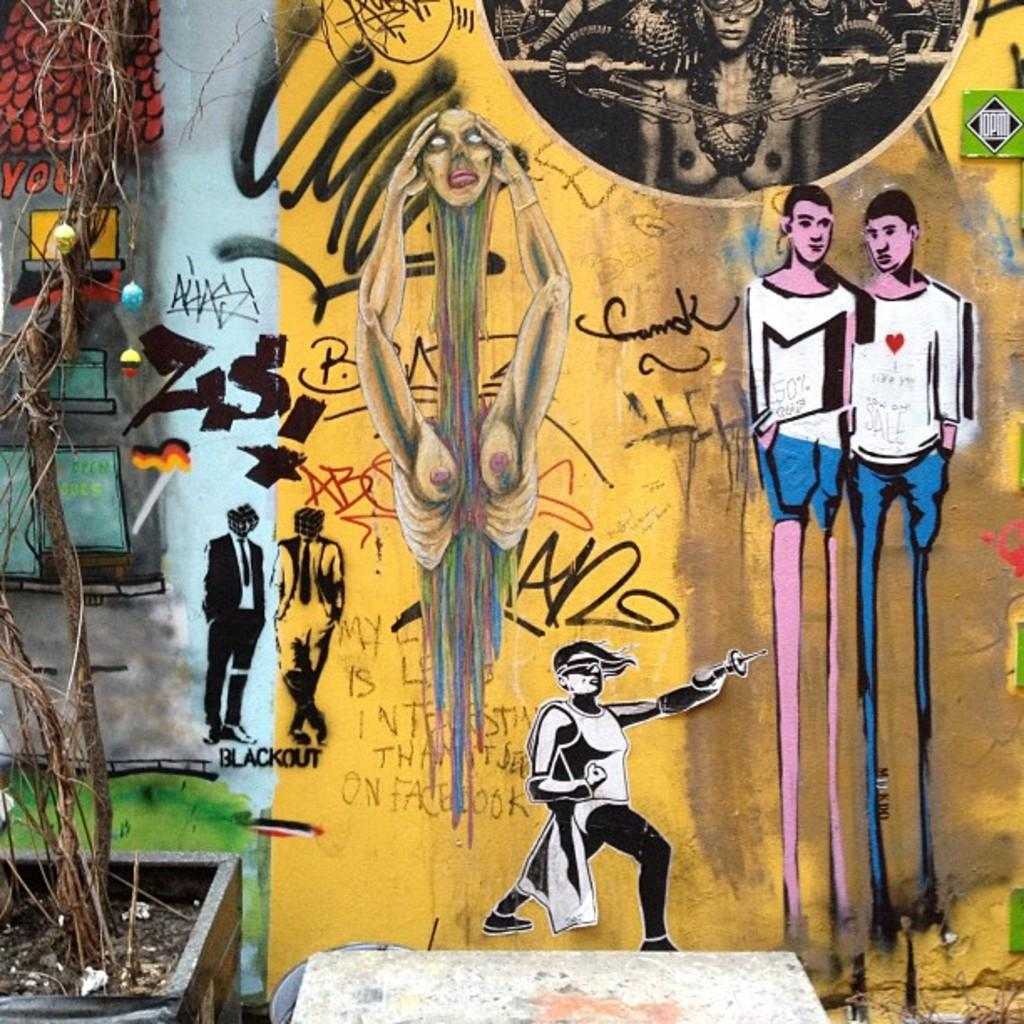What is depicted on the wall in the image? There are paintings on the wall in the image. What type of plant is in a pot in front of the wall? There is a plant in a pot in front of the wall. What else can be seen in front of the wall in the image? There are other objects in front of the wall. What is the scent of the grape in the image? There is no grape present in the image, so it is not possible to determine its scent. 